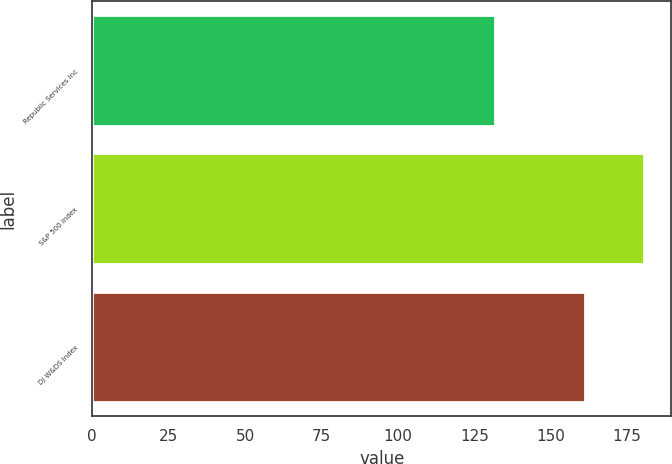<chart> <loc_0><loc_0><loc_500><loc_500><bar_chart><fcel>Republic Services Inc<fcel>S&P 500 Index<fcel>DJ W&DS Index<nl><fcel>131.91<fcel>180.44<fcel>161.31<nl></chart> 